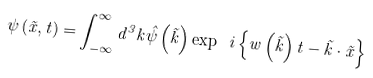<formula> <loc_0><loc_0><loc_500><loc_500>\psi \left ( { \vec { x } , t } \right ) = \int _ { - \infty } ^ { \infty } { d } ^ { 3 } k \hat { \psi } \left ( { \vec { k } } \right ) \exp \ i \left \{ { w \left ( { \vec { k } } \right ) t - \vec { k } \cdot \vec { x } } \right \}</formula> 